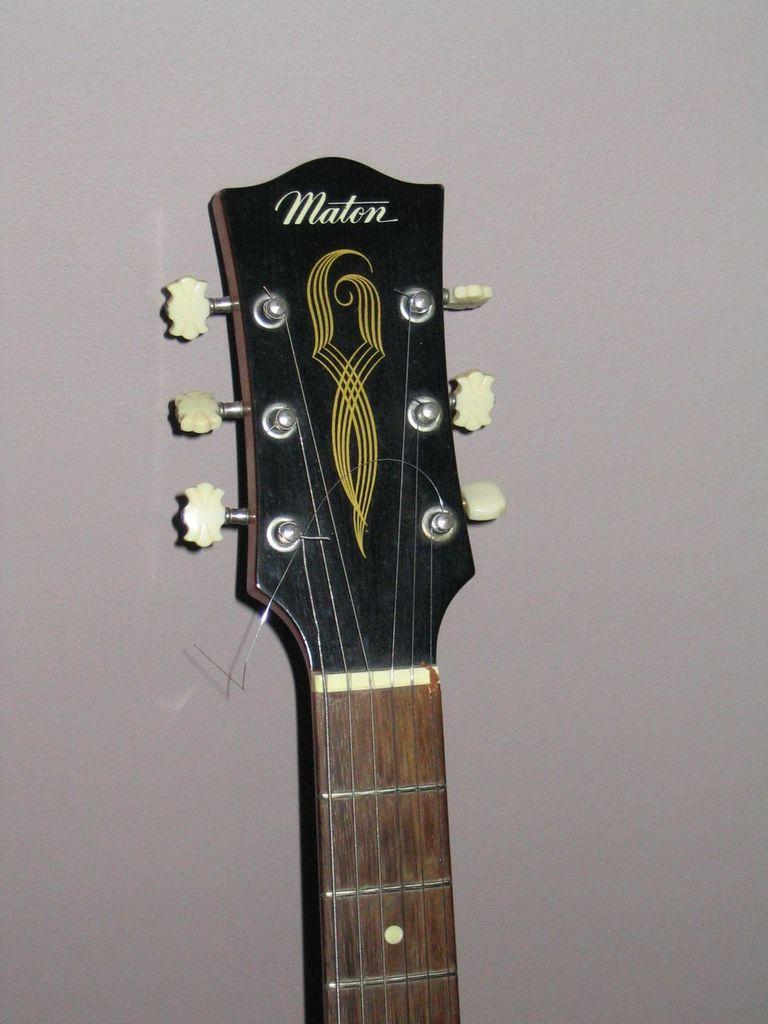What musical instrument is partially visible in the image? There is a part of a guitar in the image. What can be seen in the background of the image? There is a wall visible in the background of the image. What type of cakes are being served during the train fight in the image? There is no train, fight, or cakes present in the image; it only features a part of a guitar and a wall in the background. 